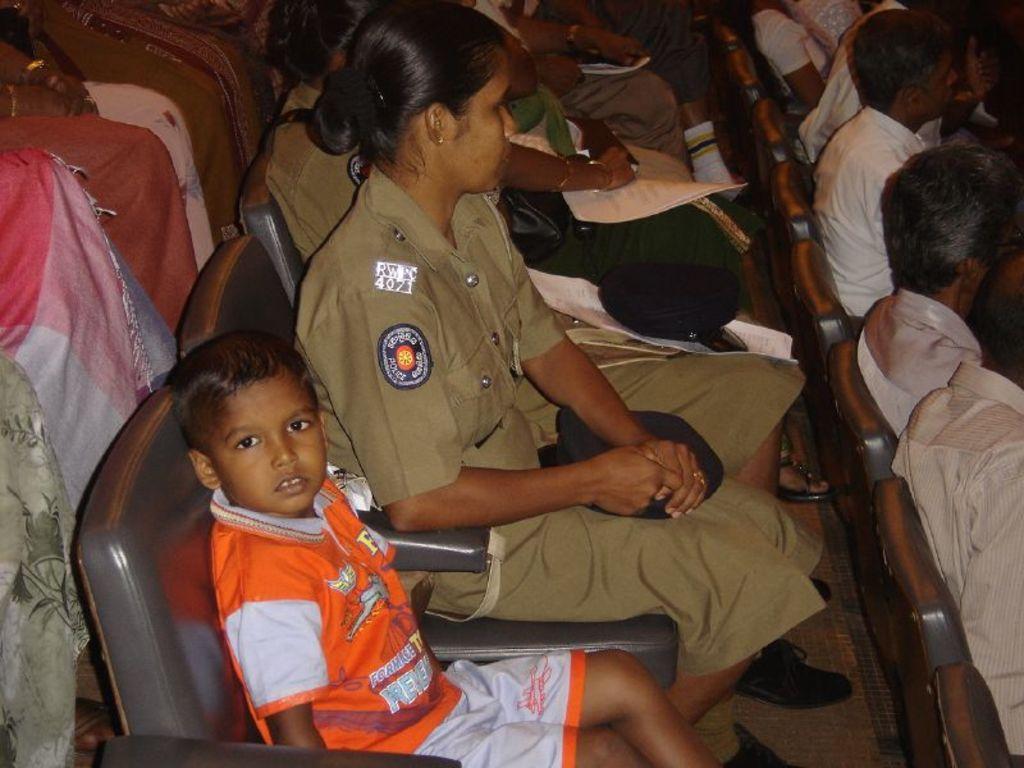In one or two sentences, can you explain what this image depicts? In this picture we can see a group of people sitting on the chairs and few people holding papers. 